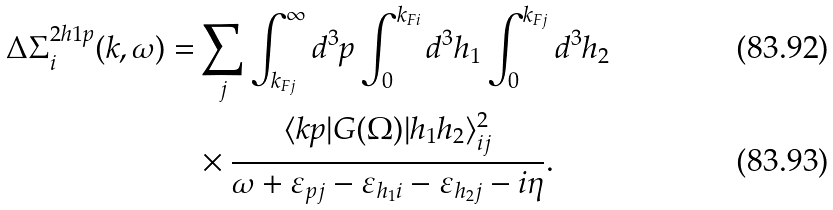<formula> <loc_0><loc_0><loc_500><loc_500>\Delta \Sigma _ { i } ^ { 2 h 1 p } ( k , \omega ) = & \sum _ { j } \int _ { k _ { F j } } ^ { \infty } d ^ { 3 } p \int _ { 0 } ^ { k _ { F i } } d ^ { 3 } h _ { 1 } \int _ { 0 } ^ { k _ { F j } } d ^ { 3 } h _ { 2 } \\ & \times \frac { \langle k p | G ( \Omega ) | h _ { 1 } h _ { 2 } \rangle _ { i j } ^ { 2 } } { \omega + \varepsilon _ { p j } - \varepsilon _ { h _ { 1 } i } - \varepsilon _ { h _ { 2 } j } - i \eta } .</formula> 